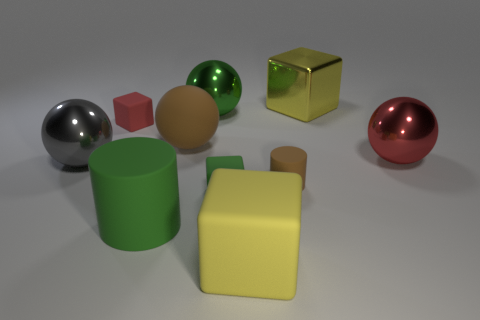Subtract 1 cubes. How many cubes are left? 3 Subtract all cubes. How many objects are left? 6 Subtract 1 brown cylinders. How many objects are left? 9 Subtract all cylinders. Subtract all large green metal cylinders. How many objects are left? 8 Add 6 red blocks. How many red blocks are left? 7 Add 8 big purple cylinders. How many big purple cylinders exist? 8 